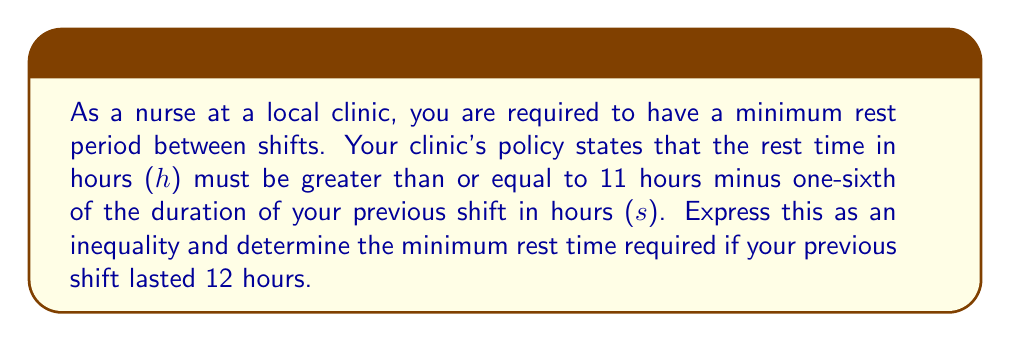Give your solution to this math problem. Let's approach this step-by-step:

1) First, we need to express the policy as an inequality:
   Rest time $\geq$ 11 hours - $\frac{1}{6}$ of previous shift duration
   
   In mathematical notation:
   $$ h \geq 11 - \frac{s}{6} $$

2) Now, we're given that the previous shift duration (s) was 12 hours. Let's substitute this into our inequality:

   $$ h \geq 11 - \frac{12}{6} $$

3) Simplify the right side of the inequality:
   $$ h \geq 11 - 2 $$
   $$ h \geq 9 $$

4) Therefore, the minimum rest time required is 9 hours.

This means that after a 12-hour shift, you must have at least 9 hours of rest before starting your next shift.
Answer: The minimum rest time required after a 12-hour shift is 9 hours. 